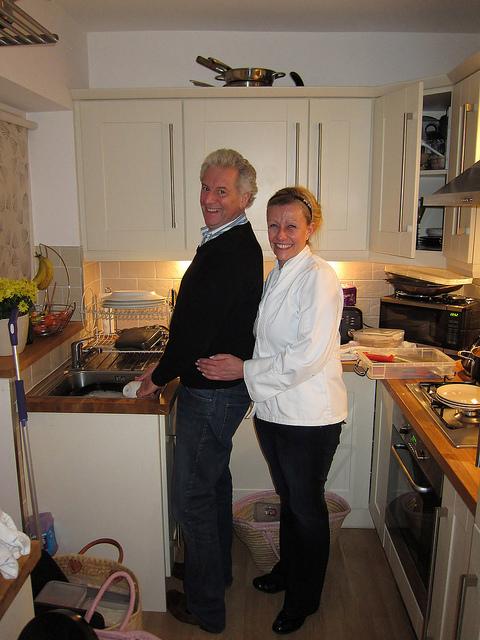Do you think she snacks often?
Be succinct. No. Is the stove full?
Be succinct. Yes. Is he wearing shorts?
Write a very short answer. No. Are these two people posing for a picture?
Short answer required. Yes. Is this a small kitchen?
Concise answer only. Yes. What color are the cabinets?
Short answer required. White. Who is doing the dishes?
Short answer required. Man. Is the man wearing pants?
Answer briefly. Yes. 